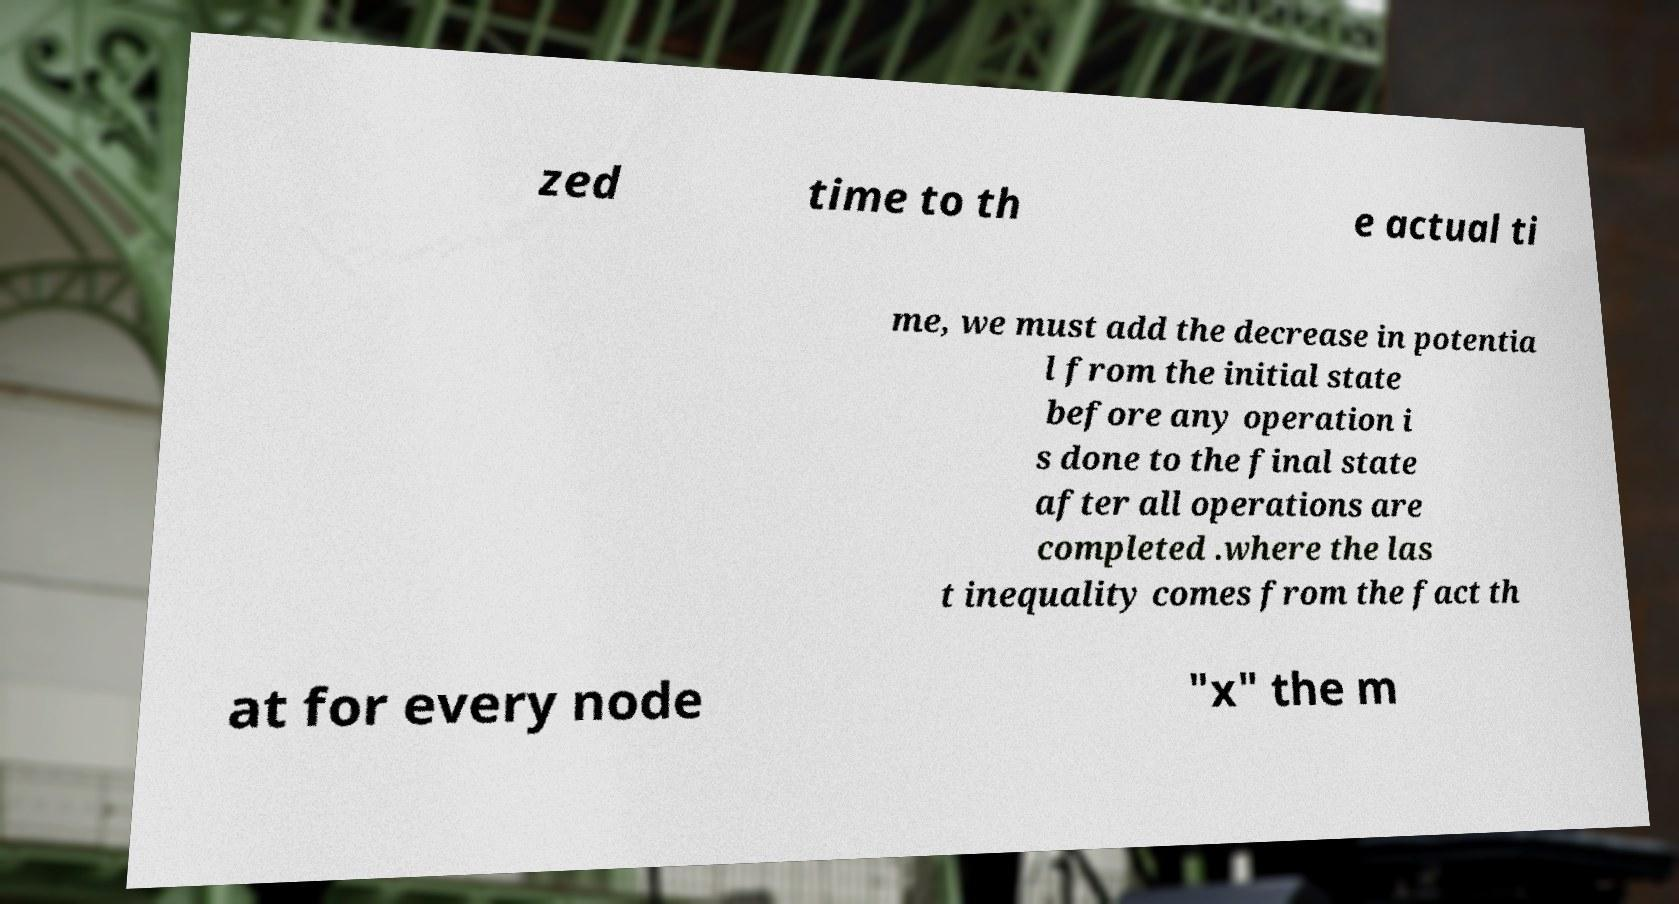Please identify and transcribe the text found in this image. zed time to th e actual ti me, we must add the decrease in potentia l from the initial state before any operation i s done to the final state after all operations are completed .where the las t inequality comes from the fact th at for every node "x" the m 